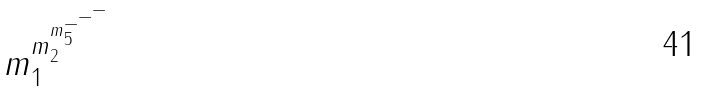<formula> <loc_0><loc_0><loc_500><loc_500>m _ { 1 } ^ { m _ { 2 } ^ { m _ { 5 } ^ { - ^ { - ^ { - } } } } }</formula> 